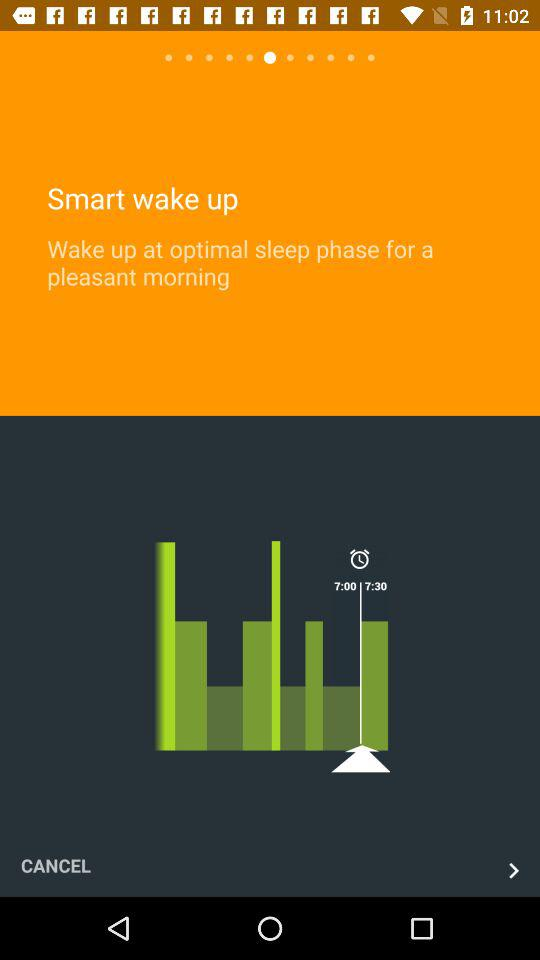How many more minutes are there between the 7:00 and 7:30 options than between the 7:00 and 7:15 options?
Answer the question using a single word or phrase. 15 